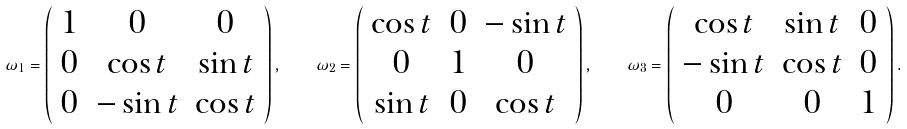<formula> <loc_0><loc_0><loc_500><loc_500>\omega _ { 1 } = \left ( \begin{array} { c c c } 1 & 0 & 0 \\ 0 & \cos t & \sin t \\ 0 & - \sin t & \cos t \end{array} \right ) , \quad \omega _ { 2 } = \left ( \begin{array} { c c c } \cos t & 0 & - \sin t \\ 0 & 1 & 0 \\ \sin t & 0 & \cos t \end{array} \right ) , \quad \omega _ { 3 } = \left ( \begin{array} { c c c } \cos t & \sin t & 0 \\ - \sin t & \cos t & 0 \\ 0 & 0 & 1 \end{array} \right ) .</formula> 